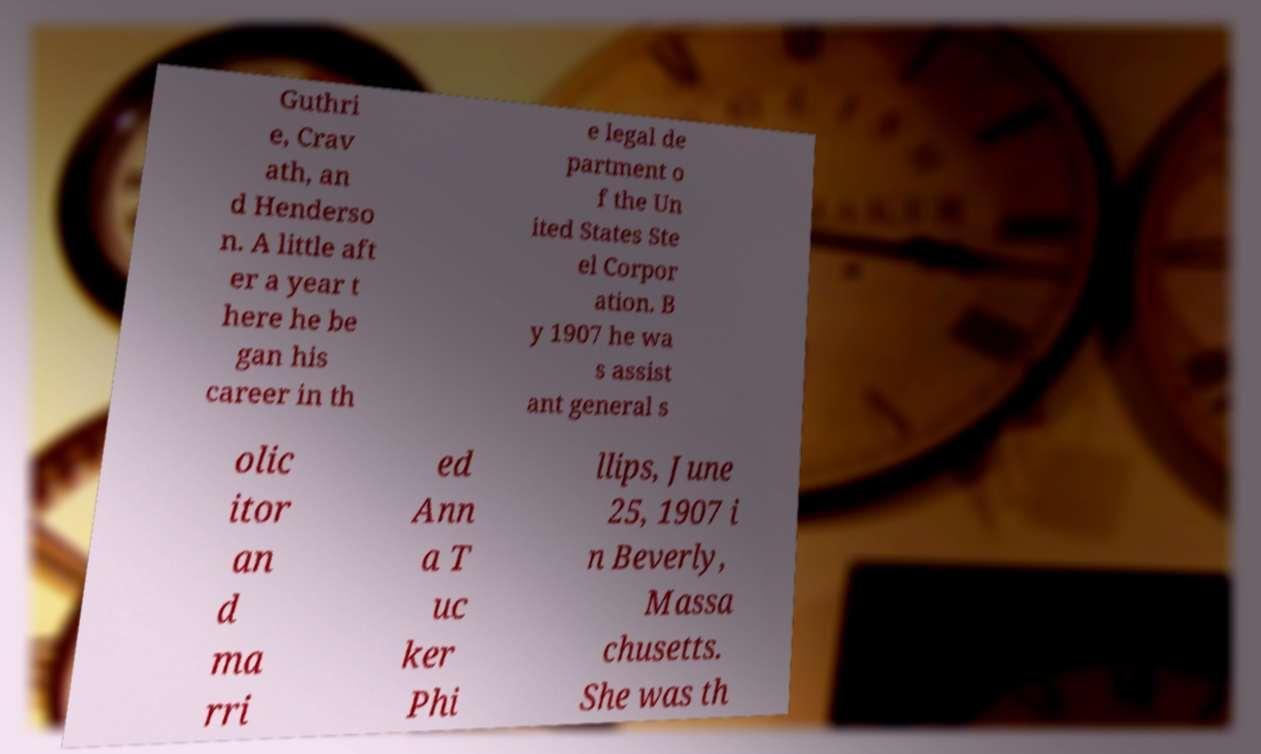Can you accurately transcribe the text from the provided image for me? Guthri e, Crav ath, an d Henderso n. A little aft er a year t here he be gan his career in th e legal de partment o f the Un ited States Ste el Corpor ation. B y 1907 he wa s assist ant general s olic itor an d ma rri ed Ann a T uc ker Phi llips, June 25, 1907 i n Beverly, Massa chusetts. She was th 